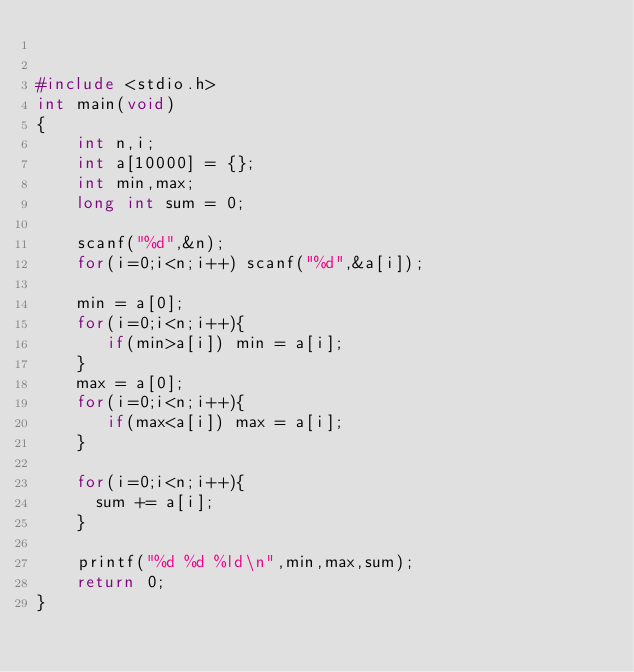Convert code to text. <code><loc_0><loc_0><loc_500><loc_500><_C_>

#include <stdio.h>
int main(void)
{
    int n,i;
    int a[10000] = {};
    int min,max;
    long int sum = 0;
 
    scanf("%d",&n);
    for(i=0;i<n;i++) scanf("%d",&a[i]);
 
    min = a[0];
    for(i=0;i<n;i++){
       if(min>a[i]) min = a[i];
    }
    max = a[0];
    for(i=0;i<n;i++){
       if(max<a[i]) max = a[i];
    }    
 
    for(i=0;i<n;i++){
      sum += a[i];
    }
     
    printf("%d %d %ld\n",min,max,sum);
    return 0;
}
 </code> 